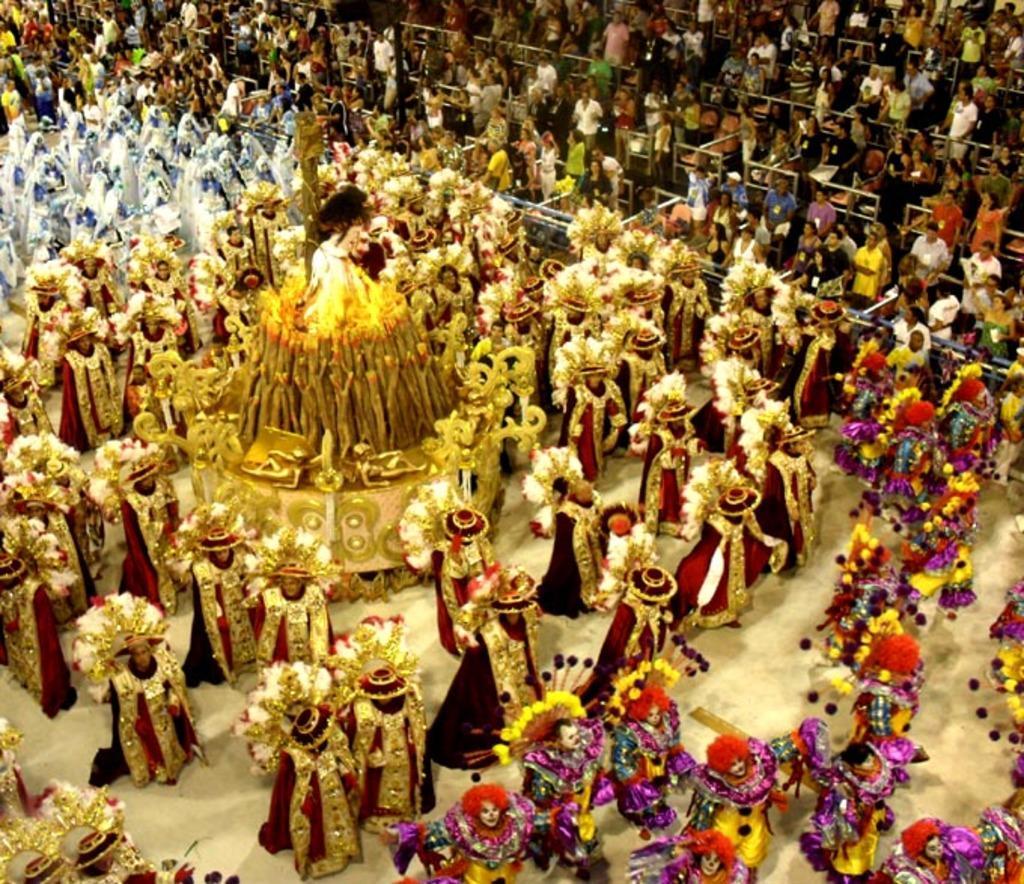How would you summarize this image in a sentence or two? In this picture we can see a group of people on the ground and they are wearing costumes and in the background we can see a group of people. 